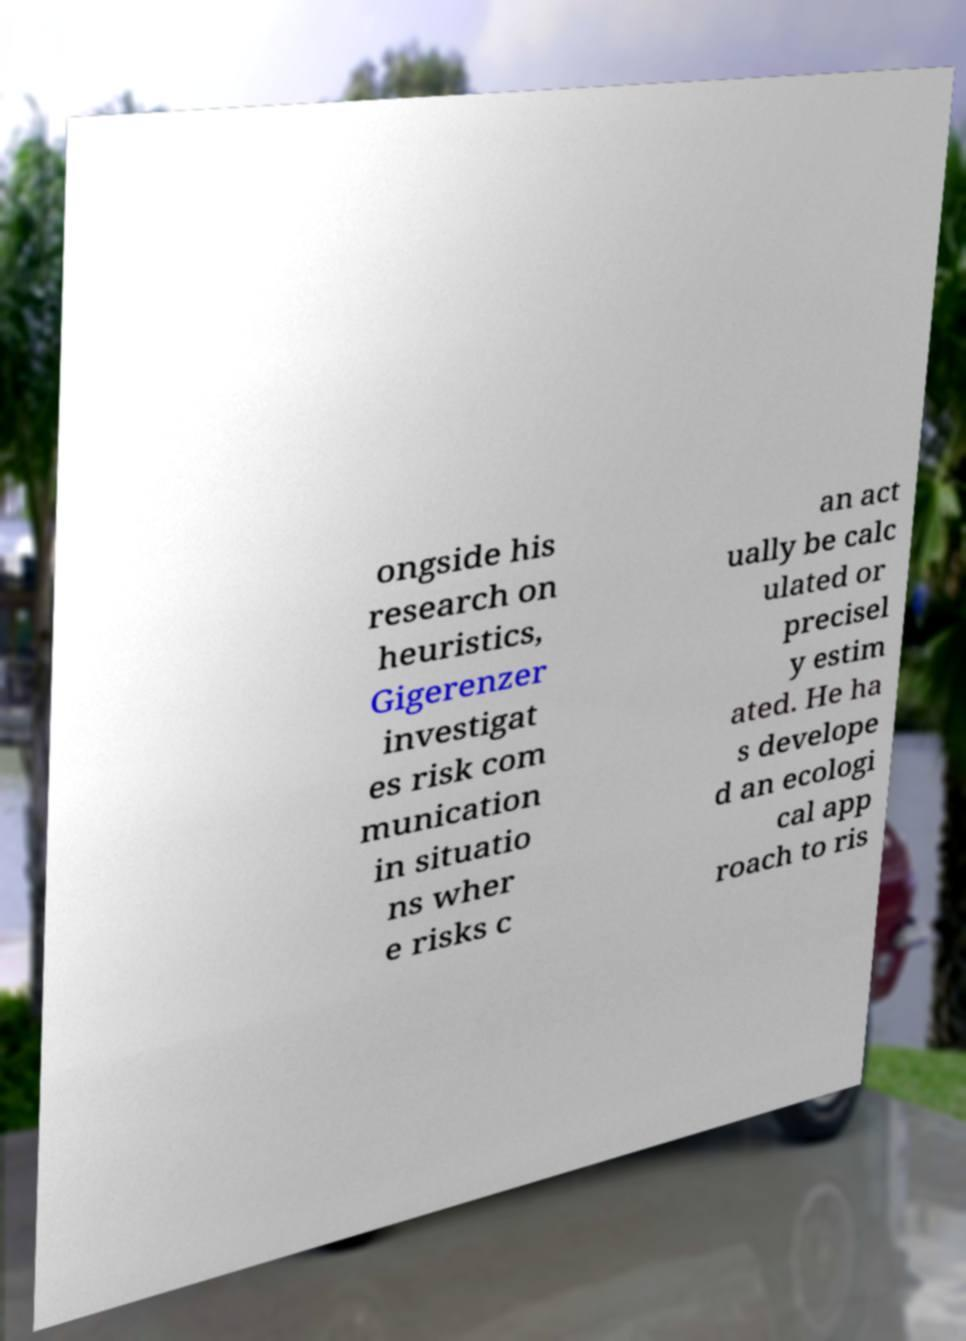Could you assist in decoding the text presented in this image and type it out clearly? ongside his research on heuristics, Gigerenzer investigat es risk com munication in situatio ns wher e risks c an act ually be calc ulated or precisel y estim ated. He ha s develope d an ecologi cal app roach to ris 